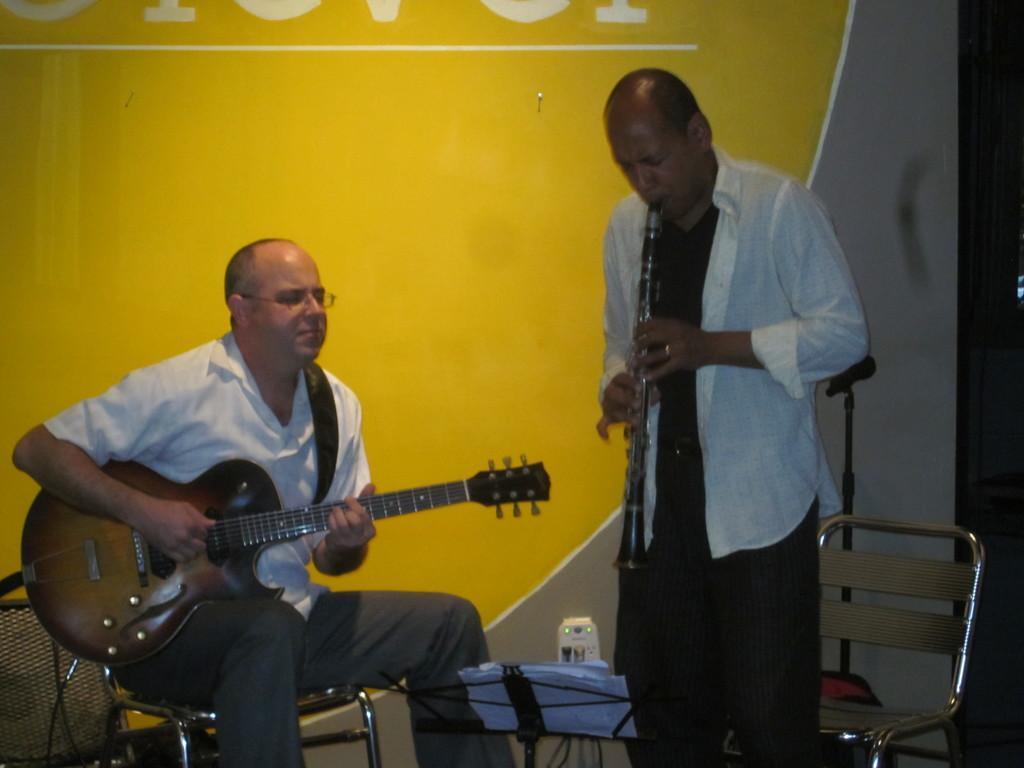How would you summarize this image in a sentence or two? In the image we can see there is a man who is sitting and holding a guitar in his hand and beside him there is a man who is standing and playing a musical instrument and at the back the wall is in yellow colour. 